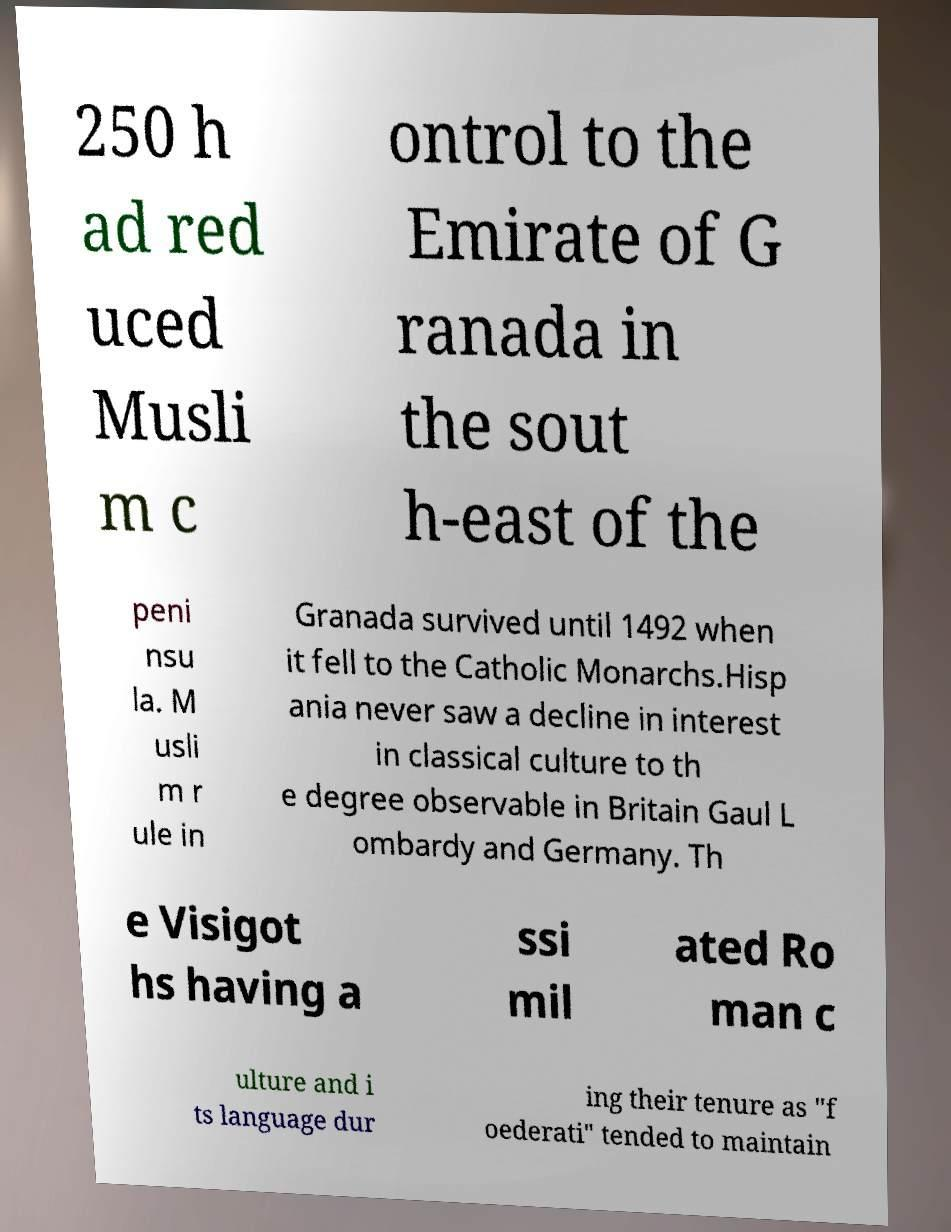Can you accurately transcribe the text from the provided image for me? 250 h ad red uced Musli m c ontrol to the Emirate of G ranada in the sout h-east of the peni nsu la. M usli m r ule in Granada survived until 1492 when it fell to the Catholic Monarchs.Hisp ania never saw a decline in interest in classical culture to th e degree observable in Britain Gaul L ombardy and Germany. Th e Visigot hs having a ssi mil ated Ro man c ulture and i ts language dur ing their tenure as "f oederati" tended to maintain 